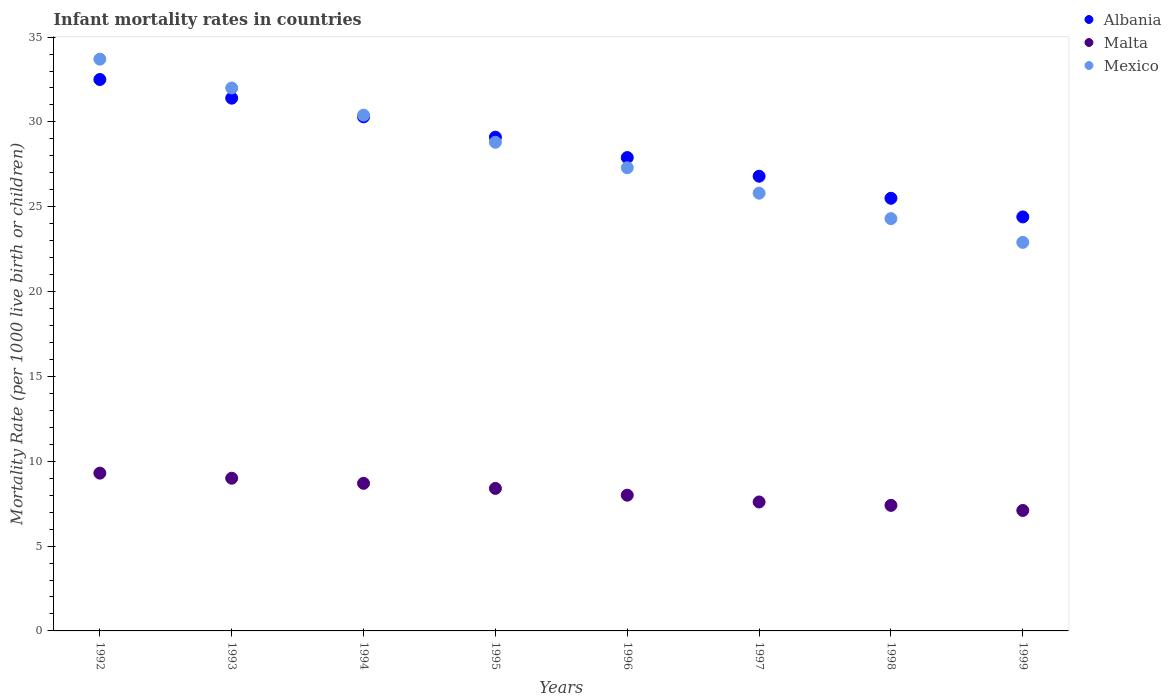What is the infant mortality rate in Mexico in 1996?
Provide a short and direct response. 27.3. Across all years, what is the minimum infant mortality rate in Albania?
Keep it short and to the point. 24.4. In which year was the infant mortality rate in Albania maximum?
Offer a terse response. 1992. In which year was the infant mortality rate in Malta minimum?
Offer a very short reply. 1999. What is the total infant mortality rate in Malta in the graph?
Provide a short and direct response. 65.5. What is the difference between the infant mortality rate in Albania in 1992 and that in 1997?
Provide a succinct answer. 5.7. What is the difference between the infant mortality rate in Malta in 1995 and the infant mortality rate in Mexico in 1999?
Your answer should be very brief. -14.5. What is the average infant mortality rate in Albania per year?
Your response must be concise. 28.49. In the year 1994, what is the difference between the infant mortality rate in Albania and infant mortality rate in Malta?
Offer a terse response. 21.6. What is the ratio of the infant mortality rate in Mexico in 1992 to that in 1999?
Your answer should be compact. 1.47. Is the infant mortality rate in Mexico in 1994 less than that in 1995?
Your response must be concise. No. Is the difference between the infant mortality rate in Albania in 1992 and 1995 greater than the difference between the infant mortality rate in Malta in 1992 and 1995?
Your answer should be compact. Yes. What is the difference between the highest and the second highest infant mortality rate in Albania?
Ensure brevity in your answer.  1.1. What is the difference between the highest and the lowest infant mortality rate in Mexico?
Provide a succinct answer. 10.8. Is the sum of the infant mortality rate in Albania in 1993 and 1998 greater than the maximum infant mortality rate in Mexico across all years?
Provide a succinct answer. Yes. Does the infant mortality rate in Mexico monotonically increase over the years?
Offer a very short reply. No. Is the infant mortality rate in Malta strictly less than the infant mortality rate in Mexico over the years?
Your answer should be compact. Yes. What is the difference between two consecutive major ticks on the Y-axis?
Make the answer very short. 5. Are the values on the major ticks of Y-axis written in scientific E-notation?
Your response must be concise. No. Does the graph contain any zero values?
Provide a succinct answer. No. How many legend labels are there?
Offer a terse response. 3. What is the title of the graph?
Your answer should be very brief. Infant mortality rates in countries. Does "Rwanda" appear as one of the legend labels in the graph?
Ensure brevity in your answer.  No. What is the label or title of the X-axis?
Your response must be concise. Years. What is the label or title of the Y-axis?
Your response must be concise. Mortality Rate (per 1000 live birth or children). What is the Mortality Rate (per 1000 live birth or children) in Albania in 1992?
Provide a short and direct response. 32.5. What is the Mortality Rate (per 1000 live birth or children) in Malta in 1992?
Ensure brevity in your answer.  9.3. What is the Mortality Rate (per 1000 live birth or children) in Mexico in 1992?
Provide a short and direct response. 33.7. What is the Mortality Rate (per 1000 live birth or children) in Albania in 1993?
Offer a terse response. 31.4. What is the Mortality Rate (per 1000 live birth or children) of Malta in 1993?
Provide a succinct answer. 9. What is the Mortality Rate (per 1000 live birth or children) of Albania in 1994?
Provide a succinct answer. 30.3. What is the Mortality Rate (per 1000 live birth or children) in Malta in 1994?
Ensure brevity in your answer.  8.7. What is the Mortality Rate (per 1000 live birth or children) in Mexico in 1994?
Your answer should be compact. 30.4. What is the Mortality Rate (per 1000 live birth or children) of Albania in 1995?
Provide a short and direct response. 29.1. What is the Mortality Rate (per 1000 live birth or children) of Mexico in 1995?
Offer a very short reply. 28.8. What is the Mortality Rate (per 1000 live birth or children) of Albania in 1996?
Provide a short and direct response. 27.9. What is the Mortality Rate (per 1000 live birth or children) in Malta in 1996?
Provide a short and direct response. 8. What is the Mortality Rate (per 1000 live birth or children) in Mexico in 1996?
Give a very brief answer. 27.3. What is the Mortality Rate (per 1000 live birth or children) in Albania in 1997?
Provide a succinct answer. 26.8. What is the Mortality Rate (per 1000 live birth or children) of Malta in 1997?
Your answer should be very brief. 7.6. What is the Mortality Rate (per 1000 live birth or children) of Mexico in 1997?
Provide a short and direct response. 25.8. What is the Mortality Rate (per 1000 live birth or children) of Mexico in 1998?
Your response must be concise. 24.3. What is the Mortality Rate (per 1000 live birth or children) of Albania in 1999?
Ensure brevity in your answer.  24.4. What is the Mortality Rate (per 1000 live birth or children) of Malta in 1999?
Provide a succinct answer. 7.1. What is the Mortality Rate (per 1000 live birth or children) of Mexico in 1999?
Provide a succinct answer. 22.9. Across all years, what is the maximum Mortality Rate (per 1000 live birth or children) in Albania?
Make the answer very short. 32.5. Across all years, what is the maximum Mortality Rate (per 1000 live birth or children) in Mexico?
Your response must be concise. 33.7. Across all years, what is the minimum Mortality Rate (per 1000 live birth or children) in Albania?
Make the answer very short. 24.4. Across all years, what is the minimum Mortality Rate (per 1000 live birth or children) in Malta?
Offer a very short reply. 7.1. Across all years, what is the minimum Mortality Rate (per 1000 live birth or children) in Mexico?
Provide a short and direct response. 22.9. What is the total Mortality Rate (per 1000 live birth or children) of Albania in the graph?
Your answer should be very brief. 227.9. What is the total Mortality Rate (per 1000 live birth or children) of Malta in the graph?
Offer a terse response. 65.5. What is the total Mortality Rate (per 1000 live birth or children) in Mexico in the graph?
Give a very brief answer. 225.2. What is the difference between the Mortality Rate (per 1000 live birth or children) of Malta in 1992 and that in 1993?
Provide a succinct answer. 0.3. What is the difference between the Mortality Rate (per 1000 live birth or children) of Mexico in 1992 and that in 1994?
Give a very brief answer. 3.3. What is the difference between the Mortality Rate (per 1000 live birth or children) of Mexico in 1992 and that in 1995?
Your answer should be very brief. 4.9. What is the difference between the Mortality Rate (per 1000 live birth or children) of Albania in 1992 and that in 1996?
Offer a very short reply. 4.6. What is the difference between the Mortality Rate (per 1000 live birth or children) of Malta in 1992 and that in 1996?
Make the answer very short. 1.3. What is the difference between the Mortality Rate (per 1000 live birth or children) in Mexico in 1992 and that in 1996?
Your answer should be very brief. 6.4. What is the difference between the Mortality Rate (per 1000 live birth or children) in Malta in 1992 and that in 1997?
Your answer should be compact. 1.7. What is the difference between the Mortality Rate (per 1000 live birth or children) of Malta in 1992 and that in 1998?
Offer a terse response. 1.9. What is the difference between the Mortality Rate (per 1000 live birth or children) of Mexico in 1992 and that in 1998?
Offer a very short reply. 9.4. What is the difference between the Mortality Rate (per 1000 live birth or children) of Albania in 1993 and that in 1994?
Offer a terse response. 1.1. What is the difference between the Mortality Rate (per 1000 live birth or children) of Albania in 1993 and that in 1995?
Keep it short and to the point. 2.3. What is the difference between the Mortality Rate (per 1000 live birth or children) of Mexico in 1993 and that in 1995?
Provide a succinct answer. 3.2. What is the difference between the Mortality Rate (per 1000 live birth or children) of Malta in 1993 and that in 1996?
Your answer should be compact. 1. What is the difference between the Mortality Rate (per 1000 live birth or children) of Mexico in 1993 and that in 1996?
Provide a succinct answer. 4.7. What is the difference between the Mortality Rate (per 1000 live birth or children) in Malta in 1993 and that in 1997?
Provide a succinct answer. 1.4. What is the difference between the Mortality Rate (per 1000 live birth or children) of Albania in 1993 and that in 1998?
Your response must be concise. 5.9. What is the difference between the Mortality Rate (per 1000 live birth or children) in Albania in 1993 and that in 1999?
Make the answer very short. 7. What is the difference between the Mortality Rate (per 1000 live birth or children) in Malta in 1994 and that in 1996?
Keep it short and to the point. 0.7. What is the difference between the Mortality Rate (per 1000 live birth or children) of Albania in 1994 and that in 1997?
Ensure brevity in your answer.  3.5. What is the difference between the Mortality Rate (per 1000 live birth or children) of Malta in 1994 and that in 1998?
Your answer should be compact. 1.3. What is the difference between the Mortality Rate (per 1000 live birth or children) of Albania in 1995 and that in 1996?
Your answer should be compact. 1.2. What is the difference between the Mortality Rate (per 1000 live birth or children) of Mexico in 1995 and that in 1997?
Ensure brevity in your answer.  3. What is the difference between the Mortality Rate (per 1000 live birth or children) in Mexico in 1995 and that in 1998?
Make the answer very short. 4.5. What is the difference between the Mortality Rate (per 1000 live birth or children) of Malta in 1995 and that in 1999?
Your response must be concise. 1.3. What is the difference between the Mortality Rate (per 1000 live birth or children) in Mexico in 1995 and that in 1999?
Make the answer very short. 5.9. What is the difference between the Mortality Rate (per 1000 live birth or children) of Albania in 1996 and that in 1997?
Ensure brevity in your answer.  1.1. What is the difference between the Mortality Rate (per 1000 live birth or children) of Malta in 1996 and that in 1998?
Ensure brevity in your answer.  0.6. What is the difference between the Mortality Rate (per 1000 live birth or children) of Albania in 1996 and that in 1999?
Your response must be concise. 3.5. What is the difference between the Mortality Rate (per 1000 live birth or children) in Mexico in 1996 and that in 1999?
Make the answer very short. 4.4. What is the difference between the Mortality Rate (per 1000 live birth or children) of Albania in 1997 and that in 1998?
Provide a short and direct response. 1.3. What is the difference between the Mortality Rate (per 1000 live birth or children) of Mexico in 1997 and that in 1999?
Ensure brevity in your answer.  2.9. What is the difference between the Mortality Rate (per 1000 live birth or children) in Malta in 1998 and that in 1999?
Provide a short and direct response. 0.3. What is the difference between the Mortality Rate (per 1000 live birth or children) in Albania in 1992 and the Mortality Rate (per 1000 live birth or children) in Malta in 1993?
Ensure brevity in your answer.  23.5. What is the difference between the Mortality Rate (per 1000 live birth or children) of Malta in 1992 and the Mortality Rate (per 1000 live birth or children) of Mexico in 1993?
Keep it short and to the point. -22.7. What is the difference between the Mortality Rate (per 1000 live birth or children) in Albania in 1992 and the Mortality Rate (per 1000 live birth or children) in Malta in 1994?
Offer a terse response. 23.8. What is the difference between the Mortality Rate (per 1000 live birth or children) of Albania in 1992 and the Mortality Rate (per 1000 live birth or children) of Mexico in 1994?
Keep it short and to the point. 2.1. What is the difference between the Mortality Rate (per 1000 live birth or children) in Malta in 1992 and the Mortality Rate (per 1000 live birth or children) in Mexico in 1994?
Provide a short and direct response. -21.1. What is the difference between the Mortality Rate (per 1000 live birth or children) in Albania in 1992 and the Mortality Rate (per 1000 live birth or children) in Malta in 1995?
Give a very brief answer. 24.1. What is the difference between the Mortality Rate (per 1000 live birth or children) of Malta in 1992 and the Mortality Rate (per 1000 live birth or children) of Mexico in 1995?
Provide a succinct answer. -19.5. What is the difference between the Mortality Rate (per 1000 live birth or children) of Albania in 1992 and the Mortality Rate (per 1000 live birth or children) of Malta in 1996?
Ensure brevity in your answer.  24.5. What is the difference between the Mortality Rate (per 1000 live birth or children) of Albania in 1992 and the Mortality Rate (per 1000 live birth or children) of Mexico in 1996?
Your answer should be compact. 5.2. What is the difference between the Mortality Rate (per 1000 live birth or children) of Albania in 1992 and the Mortality Rate (per 1000 live birth or children) of Malta in 1997?
Provide a succinct answer. 24.9. What is the difference between the Mortality Rate (per 1000 live birth or children) of Malta in 1992 and the Mortality Rate (per 1000 live birth or children) of Mexico in 1997?
Your response must be concise. -16.5. What is the difference between the Mortality Rate (per 1000 live birth or children) of Albania in 1992 and the Mortality Rate (per 1000 live birth or children) of Malta in 1998?
Your answer should be very brief. 25.1. What is the difference between the Mortality Rate (per 1000 live birth or children) of Albania in 1992 and the Mortality Rate (per 1000 live birth or children) of Malta in 1999?
Your answer should be compact. 25.4. What is the difference between the Mortality Rate (per 1000 live birth or children) of Malta in 1992 and the Mortality Rate (per 1000 live birth or children) of Mexico in 1999?
Your answer should be very brief. -13.6. What is the difference between the Mortality Rate (per 1000 live birth or children) of Albania in 1993 and the Mortality Rate (per 1000 live birth or children) of Malta in 1994?
Offer a very short reply. 22.7. What is the difference between the Mortality Rate (per 1000 live birth or children) of Malta in 1993 and the Mortality Rate (per 1000 live birth or children) of Mexico in 1994?
Your answer should be compact. -21.4. What is the difference between the Mortality Rate (per 1000 live birth or children) in Malta in 1993 and the Mortality Rate (per 1000 live birth or children) in Mexico in 1995?
Offer a terse response. -19.8. What is the difference between the Mortality Rate (per 1000 live birth or children) of Albania in 1993 and the Mortality Rate (per 1000 live birth or children) of Malta in 1996?
Your answer should be very brief. 23.4. What is the difference between the Mortality Rate (per 1000 live birth or children) in Albania in 1993 and the Mortality Rate (per 1000 live birth or children) in Mexico in 1996?
Provide a short and direct response. 4.1. What is the difference between the Mortality Rate (per 1000 live birth or children) in Malta in 1993 and the Mortality Rate (per 1000 live birth or children) in Mexico in 1996?
Give a very brief answer. -18.3. What is the difference between the Mortality Rate (per 1000 live birth or children) of Albania in 1993 and the Mortality Rate (per 1000 live birth or children) of Malta in 1997?
Your answer should be very brief. 23.8. What is the difference between the Mortality Rate (per 1000 live birth or children) in Malta in 1993 and the Mortality Rate (per 1000 live birth or children) in Mexico in 1997?
Provide a short and direct response. -16.8. What is the difference between the Mortality Rate (per 1000 live birth or children) of Albania in 1993 and the Mortality Rate (per 1000 live birth or children) of Mexico in 1998?
Your answer should be compact. 7.1. What is the difference between the Mortality Rate (per 1000 live birth or children) in Malta in 1993 and the Mortality Rate (per 1000 live birth or children) in Mexico in 1998?
Offer a terse response. -15.3. What is the difference between the Mortality Rate (per 1000 live birth or children) in Albania in 1993 and the Mortality Rate (per 1000 live birth or children) in Malta in 1999?
Offer a terse response. 24.3. What is the difference between the Mortality Rate (per 1000 live birth or children) in Albania in 1993 and the Mortality Rate (per 1000 live birth or children) in Mexico in 1999?
Keep it short and to the point. 8.5. What is the difference between the Mortality Rate (per 1000 live birth or children) of Malta in 1993 and the Mortality Rate (per 1000 live birth or children) of Mexico in 1999?
Offer a very short reply. -13.9. What is the difference between the Mortality Rate (per 1000 live birth or children) in Albania in 1994 and the Mortality Rate (per 1000 live birth or children) in Malta in 1995?
Make the answer very short. 21.9. What is the difference between the Mortality Rate (per 1000 live birth or children) of Malta in 1994 and the Mortality Rate (per 1000 live birth or children) of Mexico in 1995?
Your answer should be very brief. -20.1. What is the difference between the Mortality Rate (per 1000 live birth or children) of Albania in 1994 and the Mortality Rate (per 1000 live birth or children) of Malta in 1996?
Provide a short and direct response. 22.3. What is the difference between the Mortality Rate (per 1000 live birth or children) in Albania in 1994 and the Mortality Rate (per 1000 live birth or children) in Mexico in 1996?
Your answer should be compact. 3. What is the difference between the Mortality Rate (per 1000 live birth or children) of Malta in 1994 and the Mortality Rate (per 1000 live birth or children) of Mexico in 1996?
Offer a very short reply. -18.6. What is the difference between the Mortality Rate (per 1000 live birth or children) of Albania in 1994 and the Mortality Rate (per 1000 live birth or children) of Malta in 1997?
Your answer should be very brief. 22.7. What is the difference between the Mortality Rate (per 1000 live birth or children) in Albania in 1994 and the Mortality Rate (per 1000 live birth or children) in Mexico in 1997?
Your answer should be compact. 4.5. What is the difference between the Mortality Rate (per 1000 live birth or children) of Malta in 1994 and the Mortality Rate (per 1000 live birth or children) of Mexico in 1997?
Keep it short and to the point. -17.1. What is the difference between the Mortality Rate (per 1000 live birth or children) in Albania in 1994 and the Mortality Rate (per 1000 live birth or children) in Malta in 1998?
Keep it short and to the point. 22.9. What is the difference between the Mortality Rate (per 1000 live birth or children) of Malta in 1994 and the Mortality Rate (per 1000 live birth or children) of Mexico in 1998?
Provide a succinct answer. -15.6. What is the difference between the Mortality Rate (per 1000 live birth or children) of Albania in 1994 and the Mortality Rate (per 1000 live birth or children) of Malta in 1999?
Ensure brevity in your answer.  23.2. What is the difference between the Mortality Rate (per 1000 live birth or children) of Albania in 1994 and the Mortality Rate (per 1000 live birth or children) of Mexico in 1999?
Your answer should be very brief. 7.4. What is the difference between the Mortality Rate (per 1000 live birth or children) of Malta in 1994 and the Mortality Rate (per 1000 live birth or children) of Mexico in 1999?
Ensure brevity in your answer.  -14.2. What is the difference between the Mortality Rate (per 1000 live birth or children) of Albania in 1995 and the Mortality Rate (per 1000 live birth or children) of Malta in 1996?
Your answer should be very brief. 21.1. What is the difference between the Mortality Rate (per 1000 live birth or children) of Albania in 1995 and the Mortality Rate (per 1000 live birth or children) of Mexico in 1996?
Make the answer very short. 1.8. What is the difference between the Mortality Rate (per 1000 live birth or children) in Malta in 1995 and the Mortality Rate (per 1000 live birth or children) in Mexico in 1996?
Provide a short and direct response. -18.9. What is the difference between the Mortality Rate (per 1000 live birth or children) in Albania in 1995 and the Mortality Rate (per 1000 live birth or children) in Mexico in 1997?
Offer a terse response. 3.3. What is the difference between the Mortality Rate (per 1000 live birth or children) in Malta in 1995 and the Mortality Rate (per 1000 live birth or children) in Mexico in 1997?
Give a very brief answer. -17.4. What is the difference between the Mortality Rate (per 1000 live birth or children) in Albania in 1995 and the Mortality Rate (per 1000 live birth or children) in Malta in 1998?
Provide a short and direct response. 21.7. What is the difference between the Mortality Rate (per 1000 live birth or children) of Malta in 1995 and the Mortality Rate (per 1000 live birth or children) of Mexico in 1998?
Your answer should be very brief. -15.9. What is the difference between the Mortality Rate (per 1000 live birth or children) in Albania in 1996 and the Mortality Rate (per 1000 live birth or children) in Malta in 1997?
Offer a terse response. 20.3. What is the difference between the Mortality Rate (per 1000 live birth or children) in Malta in 1996 and the Mortality Rate (per 1000 live birth or children) in Mexico in 1997?
Your answer should be very brief. -17.8. What is the difference between the Mortality Rate (per 1000 live birth or children) of Albania in 1996 and the Mortality Rate (per 1000 live birth or children) of Malta in 1998?
Make the answer very short. 20.5. What is the difference between the Mortality Rate (per 1000 live birth or children) in Malta in 1996 and the Mortality Rate (per 1000 live birth or children) in Mexico in 1998?
Provide a short and direct response. -16.3. What is the difference between the Mortality Rate (per 1000 live birth or children) in Albania in 1996 and the Mortality Rate (per 1000 live birth or children) in Malta in 1999?
Your answer should be very brief. 20.8. What is the difference between the Mortality Rate (per 1000 live birth or children) of Malta in 1996 and the Mortality Rate (per 1000 live birth or children) of Mexico in 1999?
Offer a very short reply. -14.9. What is the difference between the Mortality Rate (per 1000 live birth or children) of Albania in 1997 and the Mortality Rate (per 1000 live birth or children) of Malta in 1998?
Offer a terse response. 19.4. What is the difference between the Mortality Rate (per 1000 live birth or children) in Malta in 1997 and the Mortality Rate (per 1000 live birth or children) in Mexico in 1998?
Your answer should be compact. -16.7. What is the difference between the Mortality Rate (per 1000 live birth or children) in Albania in 1997 and the Mortality Rate (per 1000 live birth or children) in Malta in 1999?
Make the answer very short. 19.7. What is the difference between the Mortality Rate (per 1000 live birth or children) in Malta in 1997 and the Mortality Rate (per 1000 live birth or children) in Mexico in 1999?
Provide a short and direct response. -15.3. What is the difference between the Mortality Rate (per 1000 live birth or children) in Albania in 1998 and the Mortality Rate (per 1000 live birth or children) in Malta in 1999?
Keep it short and to the point. 18.4. What is the difference between the Mortality Rate (per 1000 live birth or children) of Malta in 1998 and the Mortality Rate (per 1000 live birth or children) of Mexico in 1999?
Your answer should be very brief. -15.5. What is the average Mortality Rate (per 1000 live birth or children) of Albania per year?
Give a very brief answer. 28.49. What is the average Mortality Rate (per 1000 live birth or children) of Malta per year?
Ensure brevity in your answer.  8.19. What is the average Mortality Rate (per 1000 live birth or children) of Mexico per year?
Make the answer very short. 28.15. In the year 1992, what is the difference between the Mortality Rate (per 1000 live birth or children) in Albania and Mortality Rate (per 1000 live birth or children) in Malta?
Give a very brief answer. 23.2. In the year 1992, what is the difference between the Mortality Rate (per 1000 live birth or children) in Albania and Mortality Rate (per 1000 live birth or children) in Mexico?
Keep it short and to the point. -1.2. In the year 1992, what is the difference between the Mortality Rate (per 1000 live birth or children) of Malta and Mortality Rate (per 1000 live birth or children) of Mexico?
Your answer should be compact. -24.4. In the year 1993, what is the difference between the Mortality Rate (per 1000 live birth or children) of Albania and Mortality Rate (per 1000 live birth or children) of Malta?
Give a very brief answer. 22.4. In the year 1993, what is the difference between the Mortality Rate (per 1000 live birth or children) in Albania and Mortality Rate (per 1000 live birth or children) in Mexico?
Give a very brief answer. -0.6. In the year 1993, what is the difference between the Mortality Rate (per 1000 live birth or children) of Malta and Mortality Rate (per 1000 live birth or children) of Mexico?
Keep it short and to the point. -23. In the year 1994, what is the difference between the Mortality Rate (per 1000 live birth or children) of Albania and Mortality Rate (per 1000 live birth or children) of Malta?
Keep it short and to the point. 21.6. In the year 1994, what is the difference between the Mortality Rate (per 1000 live birth or children) in Albania and Mortality Rate (per 1000 live birth or children) in Mexico?
Give a very brief answer. -0.1. In the year 1994, what is the difference between the Mortality Rate (per 1000 live birth or children) of Malta and Mortality Rate (per 1000 live birth or children) of Mexico?
Provide a succinct answer. -21.7. In the year 1995, what is the difference between the Mortality Rate (per 1000 live birth or children) in Albania and Mortality Rate (per 1000 live birth or children) in Malta?
Your response must be concise. 20.7. In the year 1995, what is the difference between the Mortality Rate (per 1000 live birth or children) of Malta and Mortality Rate (per 1000 live birth or children) of Mexico?
Make the answer very short. -20.4. In the year 1996, what is the difference between the Mortality Rate (per 1000 live birth or children) in Malta and Mortality Rate (per 1000 live birth or children) in Mexico?
Offer a terse response. -19.3. In the year 1997, what is the difference between the Mortality Rate (per 1000 live birth or children) of Albania and Mortality Rate (per 1000 live birth or children) of Malta?
Offer a terse response. 19.2. In the year 1997, what is the difference between the Mortality Rate (per 1000 live birth or children) of Albania and Mortality Rate (per 1000 live birth or children) of Mexico?
Offer a terse response. 1. In the year 1997, what is the difference between the Mortality Rate (per 1000 live birth or children) of Malta and Mortality Rate (per 1000 live birth or children) of Mexico?
Your response must be concise. -18.2. In the year 1998, what is the difference between the Mortality Rate (per 1000 live birth or children) of Albania and Mortality Rate (per 1000 live birth or children) of Malta?
Provide a succinct answer. 18.1. In the year 1998, what is the difference between the Mortality Rate (per 1000 live birth or children) in Albania and Mortality Rate (per 1000 live birth or children) in Mexico?
Ensure brevity in your answer.  1.2. In the year 1998, what is the difference between the Mortality Rate (per 1000 live birth or children) in Malta and Mortality Rate (per 1000 live birth or children) in Mexico?
Provide a succinct answer. -16.9. In the year 1999, what is the difference between the Mortality Rate (per 1000 live birth or children) of Albania and Mortality Rate (per 1000 live birth or children) of Malta?
Your answer should be compact. 17.3. In the year 1999, what is the difference between the Mortality Rate (per 1000 live birth or children) of Albania and Mortality Rate (per 1000 live birth or children) of Mexico?
Your answer should be compact. 1.5. In the year 1999, what is the difference between the Mortality Rate (per 1000 live birth or children) in Malta and Mortality Rate (per 1000 live birth or children) in Mexico?
Offer a terse response. -15.8. What is the ratio of the Mortality Rate (per 1000 live birth or children) of Albania in 1992 to that in 1993?
Ensure brevity in your answer.  1.03. What is the ratio of the Mortality Rate (per 1000 live birth or children) of Malta in 1992 to that in 1993?
Your answer should be very brief. 1.03. What is the ratio of the Mortality Rate (per 1000 live birth or children) in Mexico in 1992 to that in 1993?
Your response must be concise. 1.05. What is the ratio of the Mortality Rate (per 1000 live birth or children) of Albania in 1992 to that in 1994?
Provide a short and direct response. 1.07. What is the ratio of the Mortality Rate (per 1000 live birth or children) of Malta in 1992 to that in 1994?
Your answer should be compact. 1.07. What is the ratio of the Mortality Rate (per 1000 live birth or children) of Mexico in 1992 to that in 1994?
Offer a very short reply. 1.11. What is the ratio of the Mortality Rate (per 1000 live birth or children) in Albania in 1992 to that in 1995?
Your response must be concise. 1.12. What is the ratio of the Mortality Rate (per 1000 live birth or children) of Malta in 1992 to that in 1995?
Provide a short and direct response. 1.11. What is the ratio of the Mortality Rate (per 1000 live birth or children) of Mexico in 1992 to that in 1995?
Provide a short and direct response. 1.17. What is the ratio of the Mortality Rate (per 1000 live birth or children) in Albania in 1992 to that in 1996?
Ensure brevity in your answer.  1.16. What is the ratio of the Mortality Rate (per 1000 live birth or children) in Malta in 1992 to that in 1996?
Your answer should be compact. 1.16. What is the ratio of the Mortality Rate (per 1000 live birth or children) in Mexico in 1992 to that in 1996?
Offer a very short reply. 1.23. What is the ratio of the Mortality Rate (per 1000 live birth or children) in Albania in 1992 to that in 1997?
Give a very brief answer. 1.21. What is the ratio of the Mortality Rate (per 1000 live birth or children) in Malta in 1992 to that in 1997?
Provide a short and direct response. 1.22. What is the ratio of the Mortality Rate (per 1000 live birth or children) in Mexico in 1992 to that in 1997?
Offer a terse response. 1.31. What is the ratio of the Mortality Rate (per 1000 live birth or children) in Albania in 1992 to that in 1998?
Make the answer very short. 1.27. What is the ratio of the Mortality Rate (per 1000 live birth or children) in Malta in 1992 to that in 1998?
Ensure brevity in your answer.  1.26. What is the ratio of the Mortality Rate (per 1000 live birth or children) of Mexico in 1992 to that in 1998?
Make the answer very short. 1.39. What is the ratio of the Mortality Rate (per 1000 live birth or children) in Albania in 1992 to that in 1999?
Keep it short and to the point. 1.33. What is the ratio of the Mortality Rate (per 1000 live birth or children) of Malta in 1992 to that in 1999?
Give a very brief answer. 1.31. What is the ratio of the Mortality Rate (per 1000 live birth or children) of Mexico in 1992 to that in 1999?
Ensure brevity in your answer.  1.47. What is the ratio of the Mortality Rate (per 1000 live birth or children) of Albania in 1993 to that in 1994?
Offer a terse response. 1.04. What is the ratio of the Mortality Rate (per 1000 live birth or children) in Malta in 1993 to that in 1994?
Give a very brief answer. 1.03. What is the ratio of the Mortality Rate (per 1000 live birth or children) in Mexico in 1993 to that in 1994?
Your answer should be very brief. 1.05. What is the ratio of the Mortality Rate (per 1000 live birth or children) of Albania in 1993 to that in 1995?
Provide a short and direct response. 1.08. What is the ratio of the Mortality Rate (per 1000 live birth or children) in Malta in 1993 to that in 1995?
Your answer should be very brief. 1.07. What is the ratio of the Mortality Rate (per 1000 live birth or children) of Mexico in 1993 to that in 1995?
Provide a short and direct response. 1.11. What is the ratio of the Mortality Rate (per 1000 live birth or children) of Albania in 1993 to that in 1996?
Ensure brevity in your answer.  1.13. What is the ratio of the Mortality Rate (per 1000 live birth or children) in Malta in 1993 to that in 1996?
Your response must be concise. 1.12. What is the ratio of the Mortality Rate (per 1000 live birth or children) in Mexico in 1993 to that in 1996?
Your answer should be very brief. 1.17. What is the ratio of the Mortality Rate (per 1000 live birth or children) of Albania in 1993 to that in 1997?
Provide a succinct answer. 1.17. What is the ratio of the Mortality Rate (per 1000 live birth or children) of Malta in 1993 to that in 1997?
Your response must be concise. 1.18. What is the ratio of the Mortality Rate (per 1000 live birth or children) in Mexico in 1993 to that in 1997?
Give a very brief answer. 1.24. What is the ratio of the Mortality Rate (per 1000 live birth or children) in Albania in 1993 to that in 1998?
Offer a very short reply. 1.23. What is the ratio of the Mortality Rate (per 1000 live birth or children) of Malta in 1993 to that in 1998?
Your response must be concise. 1.22. What is the ratio of the Mortality Rate (per 1000 live birth or children) in Mexico in 1993 to that in 1998?
Your answer should be compact. 1.32. What is the ratio of the Mortality Rate (per 1000 live birth or children) of Albania in 1993 to that in 1999?
Provide a short and direct response. 1.29. What is the ratio of the Mortality Rate (per 1000 live birth or children) of Malta in 1993 to that in 1999?
Provide a short and direct response. 1.27. What is the ratio of the Mortality Rate (per 1000 live birth or children) in Mexico in 1993 to that in 1999?
Your answer should be very brief. 1.4. What is the ratio of the Mortality Rate (per 1000 live birth or children) of Albania in 1994 to that in 1995?
Give a very brief answer. 1.04. What is the ratio of the Mortality Rate (per 1000 live birth or children) of Malta in 1994 to that in 1995?
Ensure brevity in your answer.  1.04. What is the ratio of the Mortality Rate (per 1000 live birth or children) in Mexico in 1994 to that in 1995?
Ensure brevity in your answer.  1.06. What is the ratio of the Mortality Rate (per 1000 live birth or children) in Albania in 1994 to that in 1996?
Ensure brevity in your answer.  1.09. What is the ratio of the Mortality Rate (per 1000 live birth or children) of Malta in 1994 to that in 1996?
Provide a short and direct response. 1.09. What is the ratio of the Mortality Rate (per 1000 live birth or children) in Mexico in 1994 to that in 1996?
Your response must be concise. 1.11. What is the ratio of the Mortality Rate (per 1000 live birth or children) in Albania in 1994 to that in 1997?
Ensure brevity in your answer.  1.13. What is the ratio of the Mortality Rate (per 1000 live birth or children) of Malta in 1994 to that in 1997?
Ensure brevity in your answer.  1.14. What is the ratio of the Mortality Rate (per 1000 live birth or children) of Mexico in 1994 to that in 1997?
Make the answer very short. 1.18. What is the ratio of the Mortality Rate (per 1000 live birth or children) of Albania in 1994 to that in 1998?
Keep it short and to the point. 1.19. What is the ratio of the Mortality Rate (per 1000 live birth or children) in Malta in 1994 to that in 1998?
Provide a succinct answer. 1.18. What is the ratio of the Mortality Rate (per 1000 live birth or children) in Mexico in 1994 to that in 1998?
Your answer should be compact. 1.25. What is the ratio of the Mortality Rate (per 1000 live birth or children) in Albania in 1994 to that in 1999?
Offer a very short reply. 1.24. What is the ratio of the Mortality Rate (per 1000 live birth or children) of Malta in 1994 to that in 1999?
Your response must be concise. 1.23. What is the ratio of the Mortality Rate (per 1000 live birth or children) in Mexico in 1994 to that in 1999?
Provide a short and direct response. 1.33. What is the ratio of the Mortality Rate (per 1000 live birth or children) of Albania in 1995 to that in 1996?
Keep it short and to the point. 1.04. What is the ratio of the Mortality Rate (per 1000 live birth or children) in Malta in 1995 to that in 1996?
Offer a very short reply. 1.05. What is the ratio of the Mortality Rate (per 1000 live birth or children) of Mexico in 1995 to that in 1996?
Provide a short and direct response. 1.05. What is the ratio of the Mortality Rate (per 1000 live birth or children) of Albania in 1995 to that in 1997?
Offer a terse response. 1.09. What is the ratio of the Mortality Rate (per 1000 live birth or children) of Malta in 1995 to that in 1997?
Ensure brevity in your answer.  1.11. What is the ratio of the Mortality Rate (per 1000 live birth or children) in Mexico in 1995 to that in 1997?
Give a very brief answer. 1.12. What is the ratio of the Mortality Rate (per 1000 live birth or children) of Albania in 1995 to that in 1998?
Provide a short and direct response. 1.14. What is the ratio of the Mortality Rate (per 1000 live birth or children) of Malta in 1995 to that in 1998?
Offer a terse response. 1.14. What is the ratio of the Mortality Rate (per 1000 live birth or children) in Mexico in 1995 to that in 1998?
Offer a very short reply. 1.19. What is the ratio of the Mortality Rate (per 1000 live birth or children) in Albania in 1995 to that in 1999?
Provide a succinct answer. 1.19. What is the ratio of the Mortality Rate (per 1000 live birth or children) in Malta in 1995 to that in 1999?
Ensure brevity in your answer.  1.18. What is the ratio of the Mortality Rate (per 1000 live birth or children) of Mexico in 1995 to that in 1999?
Make the answer very short. 1.26. What is the ratio of the Mortality Rate (per 1000 live birth or children) of Albania in 1996 to that in 1997?
Offer a very short reply. 1.04. What is the ratio of the Mortality Rate (per 1000 live birth or children) in Malta in 1996 to that in 1997?
Your response must be concise. 1.05. What is the ratio of the Mortality Rate (per 1000 live birth or children) in Mexico in 1996 to that in 1997?
Provide a succinct answer. 1.06. What is the ratio of the Mortality Rate (per 1000 live birth or children) in Albania in 1996 to that in 1998?
Ensure brevity in your answer.  1.09. What is the ratio of the Mortality Rate (per 1000 live birth or children) in Malta in 1996 to that in 1998?
Your answer should be very brief. 1.08. What is the ratio of the Mortality Rate (per 1000 live birth or children) of Mexico in 1996 to that in 1998?
Your answer should be very brief. 1.12. What is the ratio of the Mortality Rate (per 1000 live birth or children) in Albania in 1996 to that in 1999?
Offer a terse response. 1.14. What is the ratio of the Mortality Rate (per 1000 live birth or children) in Malta in 1996 to that in 1999?
Make the answer very short. 1.13. What is the ratio of the Mortality Rate (per 1000 live birth or children) in Mexico in 1996 to that in 1999?
Ensure brevity in your answer.  1.19. What is the ratio of the Mortality Rate (per 1000 live birth or children) in Albania in 1997 to that in 1998?
Keep it short and to the point. 1.05. What is the ratio of the Mortality Rate (per 1000 live birth or children) in Mexico in 1997 to that in 1998?
Keep it short and to the point. 1.06. What is the ratio of the Mortality Rate (per 1000 live birth or children) of Albania in 1997 to that in 1999?
Provide a short and direct response. 1.1. What is the ratio of the Mortality Rate (per 1000 live birth or children) of Malta in 1997 to that in 1999?
Your response must be concise. 1.07. What is the ratio of the Mortality Rate (per 1000 live birth or children) in Mexico in 1997 to that in 1999?
Offer a terse response. 1.13. What is the ratio of the Mortality Rate (per 1000 live birth or children) in Albania in 1998 to that in 1999?
Offer a very short reply. 1.05. What is the ratio of the Mortality Rate (per 1000 live birth or children) in Malta in 1998 to that in 1999?
Your answer should be compact. 1.04. What is the ratio of the Mortality Rate (per 1000 live birth or children) in Mexico in 1998 to that in 1999?
Offer a very short reply. 1.06. What is the difference between the highest and the second highest Mortality Rate (per 1000 live birth or children) in Mexico?
Offer a very short reply. 1.7. What is the difference between the highest and the lowest Mortality Rate (per 1000 live birth or children) in Mexico?
Offer a terse response. 10.8. 